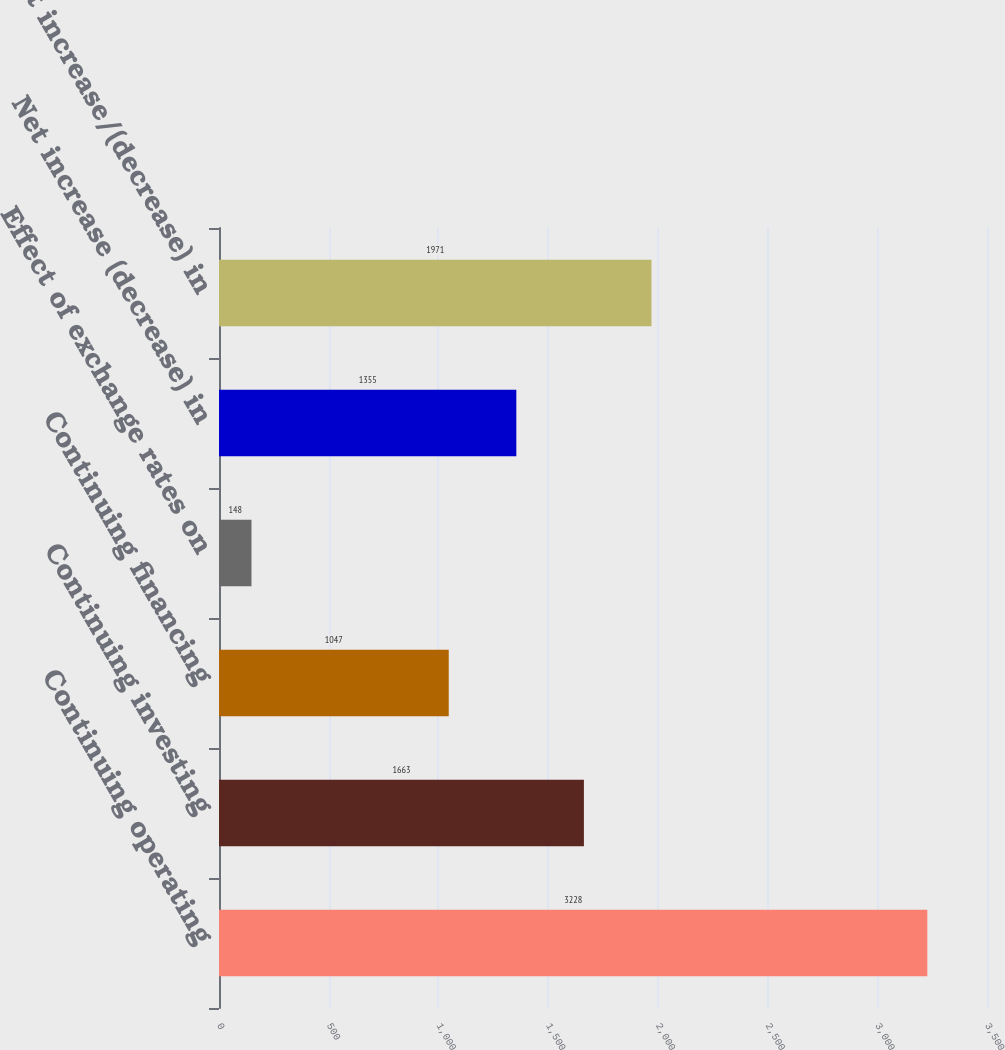Convert chart. <chart><loc_0><loc_0><loc_500><loc_500><bar_chart><fcel>Continuing operating<fcel>Continuing investing<fcel>Continuing financing<fcel>Effect of exchange rates on<fcel>Net increase (decrease) in<fcel>Net increase/(decrease) in<nl><fcel>3228<fcel>1663<fcel>1047<fcel>148<fcel>1355<fcel>1971<nl></chart> 